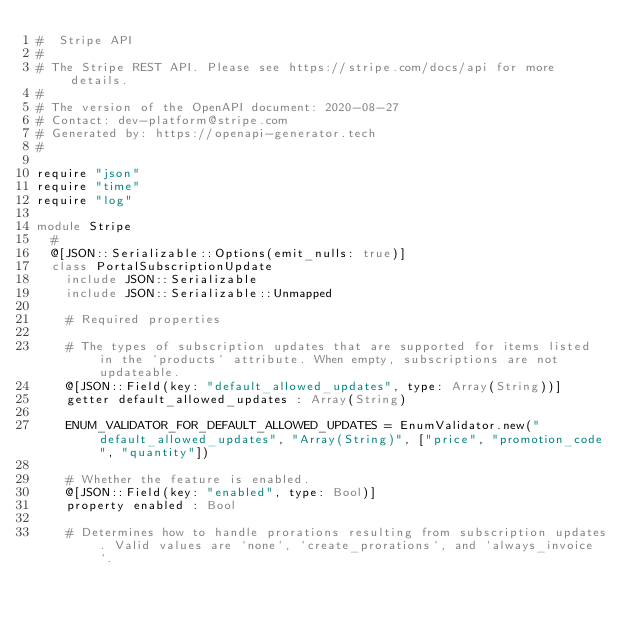<code> <loc_0><loc_0><loc_500><loc_500><_Crystal_>#  Stripe API
#
# The Stripe REST API. Please see https://stripe.com/docs/api for more details.
#
# The version of the OpenAPI document: 2020-08-27
# Contact: dev-platform@stripe.com
# Generated by: https://openapi-generator.tech
#

require "json"
require "time"
require "log"

module Stripe
  #
  @[JSON::Serializable::Options(emit_nulls: true)]
  class PortalSubscriptionUpdate
    include JSON::Serializable
    include JSON::Serializable::Unmapped

    # Required properties

    # The types of subscription updates that are supported for items listed in the `products` attribute. When empty, subscriptions are not updateable.
    @[JSON::Field(key: "default_allowed_updates", type: Array(String))]
    getter default_allowed_updates : Array(String)

    ENUM_VALIDATOR_FOR_DEFAULT_ALLOWED_UPDATES = EnumValidator.new("default_allowed_updates", "Array(String)", ["price", "promotion_code", "quantity"])

    # Whether the feature is enabled.
    @[JSON::Field(key: "enabled", type: Bool)]
    property enabled : Bool

    # Determines how to handle prorations resulting from subscription updates. Valid values are `none`, `create_prorations`, and `always_invoice`.</code> 